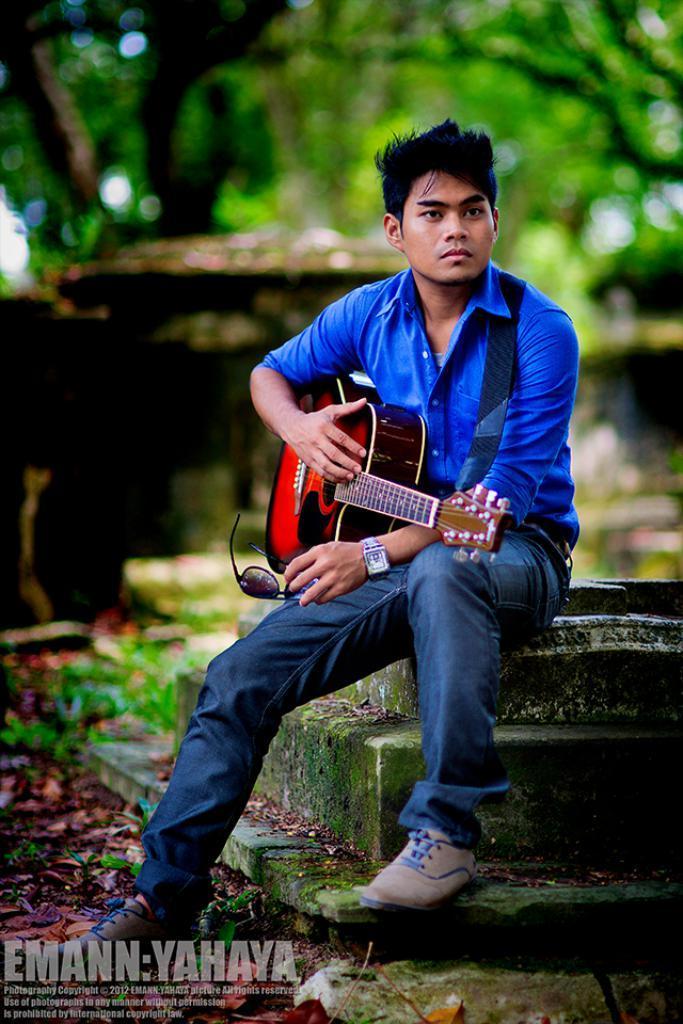Describe this image in one or two sentences. This is a picture of a man sitting on a wall the man is holding the guitar and the goggles. The man having a watch to his right hand background of the man there is a trees with a blur and there is a water mark in the image. 